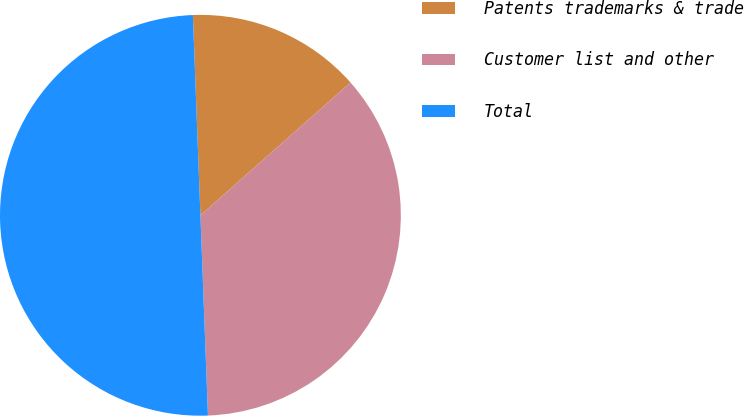Convert chart. <chart><loc_0><loc_0><loc_500><loc_500><pie_chart><fcel>Patents trademarks & trade<fcel>Customer list and other<fcel>Total<nl><fcel>14.07%<fcel>35.93%<fcel>50.0%<nl></chart> 